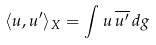Convert formula to latex. <formula><loc_0><loc_0><loc_500><loc_500>\langle u , u ^ { \prime } \rangle _ { X } = \int u \, \overline { u ^ { \prime } } \, d g</formula> 